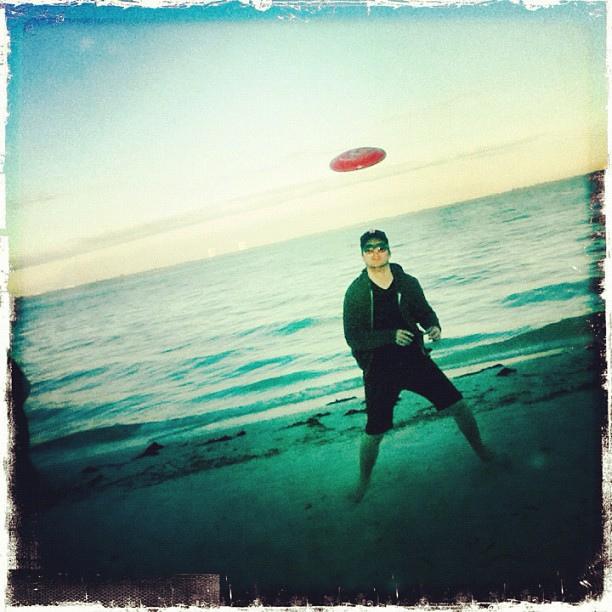What is he about to catch?
Quick response, please. Frisbee. Is this near water?
Answer briefly. Yes. What color is the frisbee?
Quick response, please. Red. 